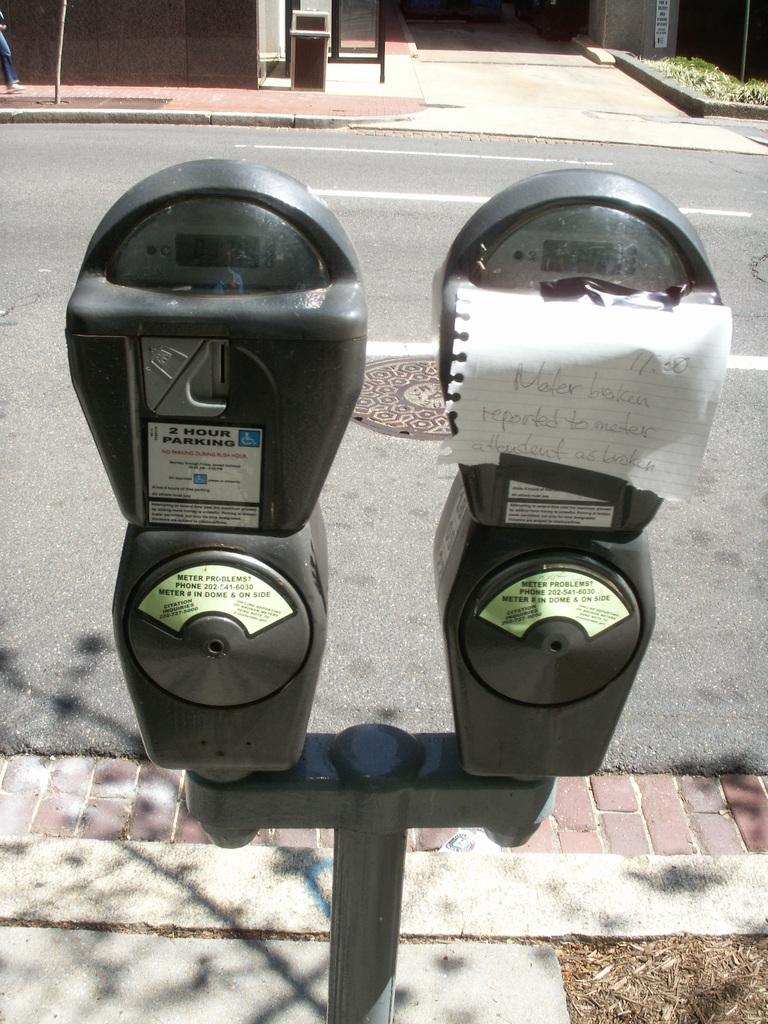<image>
Offer a succinct explanation of the picture presented. A piece of notebook paper has been taped over a road meter that reads "meter broken, reported to meter attendant as broken" 